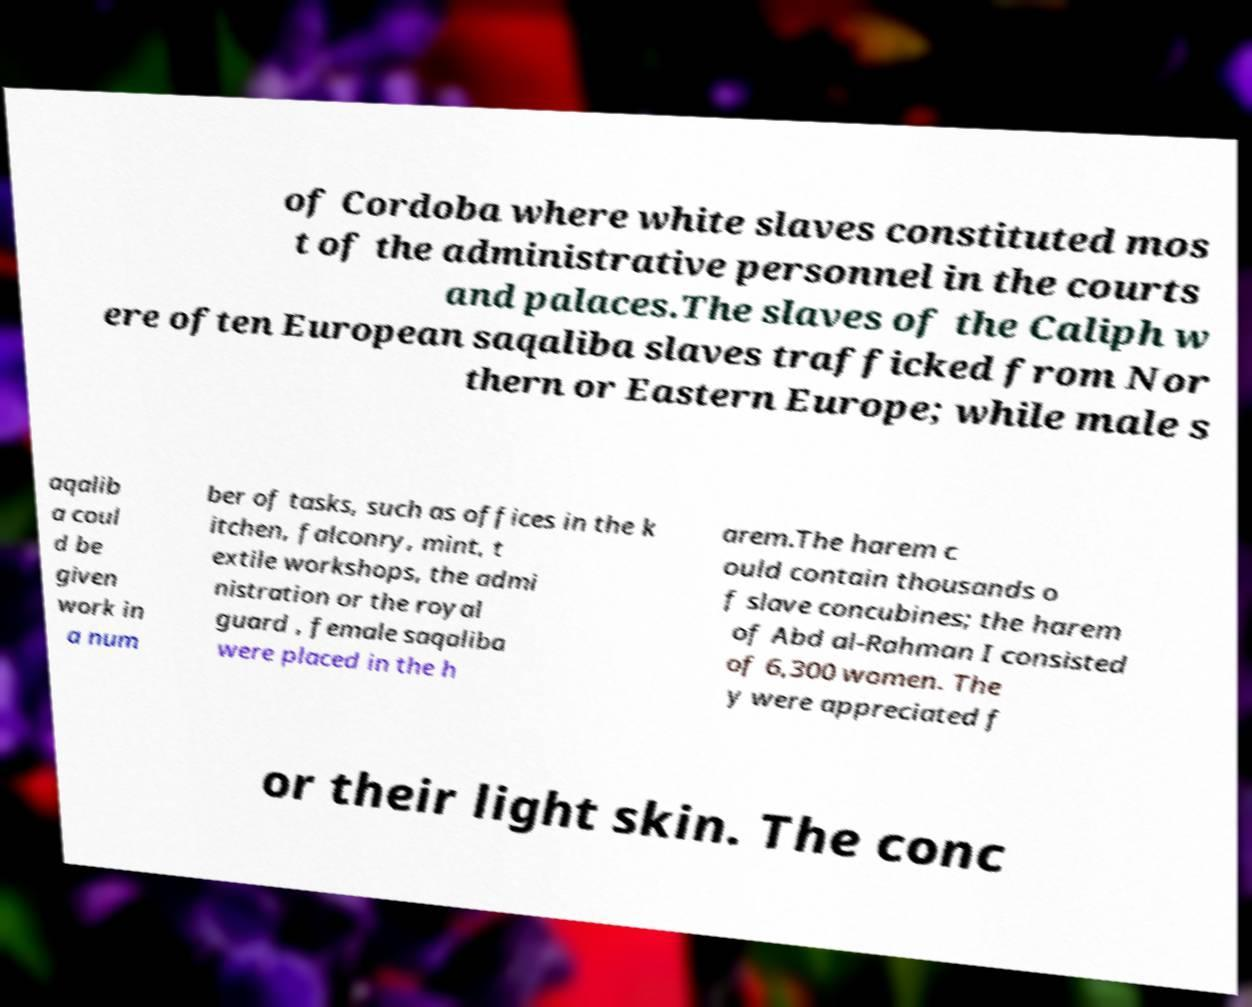What messages or text are displayed in this image? I need them in a readable, typed format. of Cordoba where white slaves constituted mos t of the administrative personnel in the courts and palaces.The slaves of the Caliph w ere often European saqaliba slaves trafficked from Nor thern or Eastern Europe; while male s aqalib a coul d be given work in a num ber of tasks, such as offices in the k itchen, falconry, mint, t extile workshops, the admi nistration or the royal guard , female saqaliba were placed in the h arem.The harem c ould contain thousands o f slave concubines; the harem of Abd al-Rahman I consisted of 6,300 women. The y were appreciated f or their light skin. The conc 